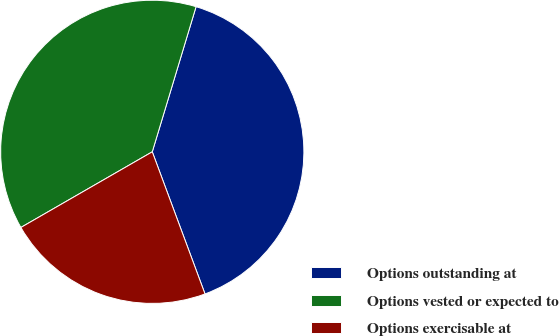<chart> <loc_0><loc_0><loc_500><loc_500><pie_chart><fcel>Options outstanding at<fcel>Options vested or expected to<fcel>Options exercisable at<nl><fcel>39.68%<fcel>37.98%<fcel>22.34%<nl></chart> 